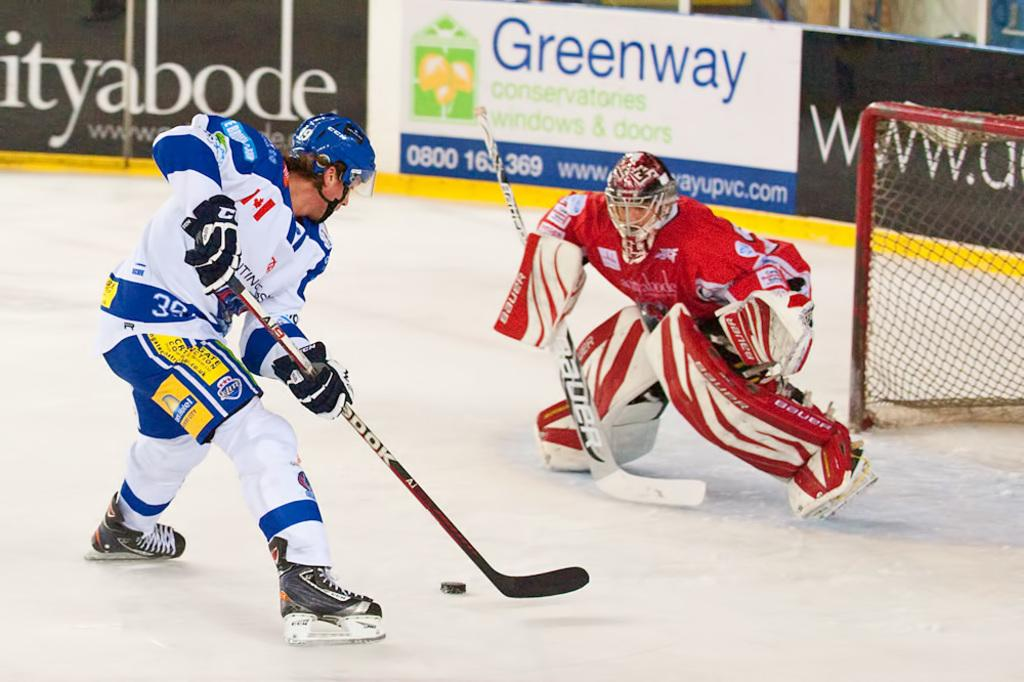<image>
Provide a brief description of the given image. a player in white with the number 3 on their jersey 